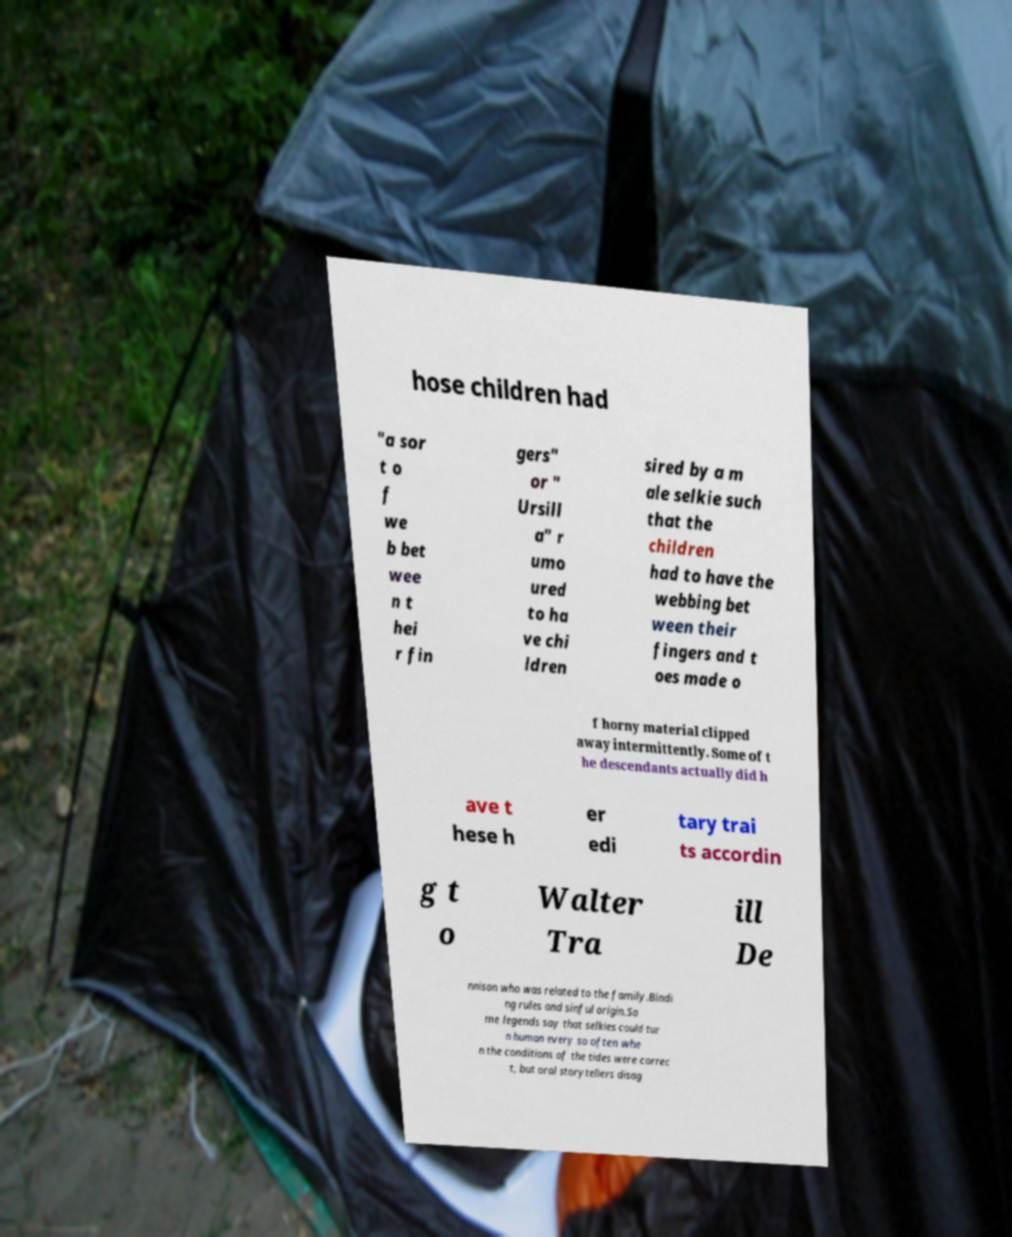Please read and relay the text visible in this image. What does it say? hose children had "a sor t o f we b bet wee n t hei r fin gers" or " Ursill a" r umo ured to ha ve chi ldren sired by a m ale selkie such that the children had to have the webbing bet ween their fingers and t oes made o f horny material clipped away intermittently. Some of t he descendants actually did h ave t hese h er edi tary trai ts accordin g t o Walter Tra ill De nnison who was related to the family.Bindi ng rules and sinful origin.So me legends say that selkies could tur n human every so often whe n the conditions of the tides were correc t, but oral storytellers disag 